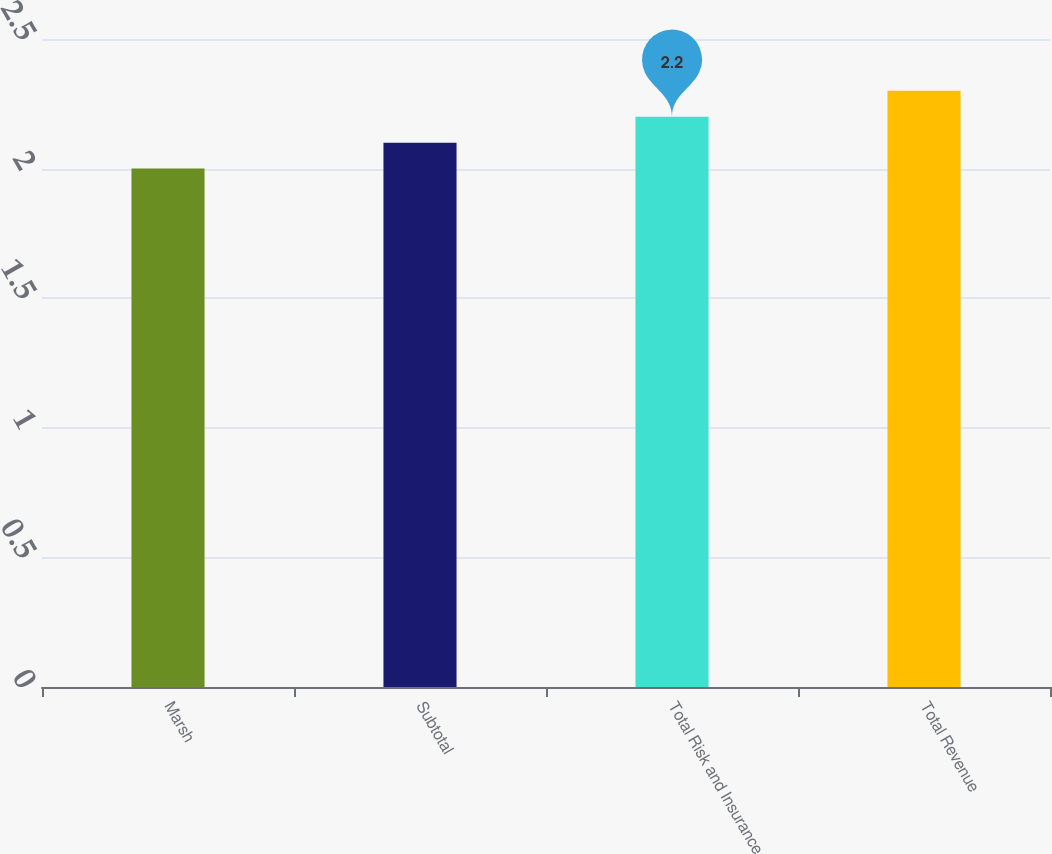<chart> <loc_0><loc_0><loc_500><loc_500><bar_chart><fcel>Marsh<fcel>Subtotal<fcel>Total Risk and Insurance<fcel>Total Revenue<nl><fcel>2<fcel>2.1<fcel>2.2<fcel>2.3<nl></chart> 